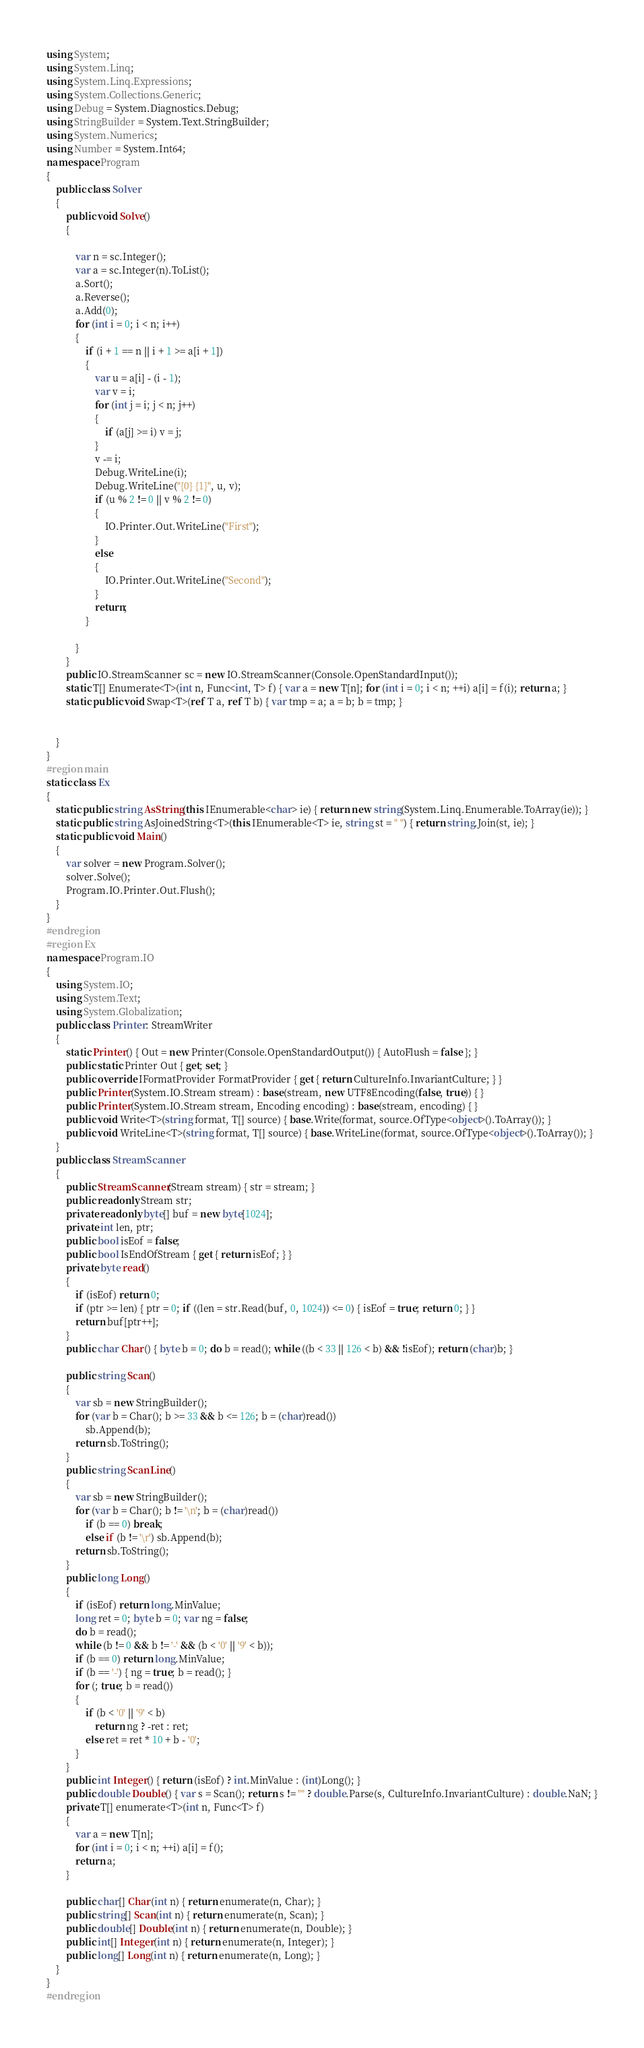Convert code to text. <code><loc_0><loc_0><loc_500><loc_500><_C#_>using System;
using System.Linq;
using System.Linq.Expressions;
using System.Collections.Generic;
using Debug = System.Diagnostics.Debug;
using StringBuilder = System.Text.StringBuilder;
using System.Numerics;
using Number = System.Int64;
namespace Program
{
    public class Solver
    {
        public void Solve()
        {

            var n = sc.Integer();
            var a = sc.Integer(n).ToList();
            a.Sort();
            a.Reverse();
            a.Add(0);
            for (int i = 0; i < n; i++)
            {
                if (i + 1 == n || i + 1 >= a[i + 1])
                {
                    var u = a[i] - (i - 1);
                    var v = i;
                    for (int j = i; j < n; j++)
                    {
                        if (a[j] >= i) v = j;
                    }
                    v -= i;
                    Debug.WriteLine(i);
                    Debug.WriteLine("{0} {1}", u, v);
                    if (u % 2 != 0 || v % 2 != 0)
                    {
                        IO.Printer.Out.WriteLine("First");
                    }
                    else
                    {
                        IO.Printer.Out.WriteLine("Second");
                    }
                    return;
                }

            }
        }
        public IO.StreamScanner sc = new IO.StreamScanner(Console.OpenStandardInput());
        static T[] Enumerate<T>(int n, Func<int, T> f) { var a = new T[n]; for (int i = 0; i < n; ++i) a[i] = f(i); return a; }
        static public void Swap<T>(ref T a, ref T b) { var tmp = a; a = b; b = tmp; }


    }
}
#region main
static class Ex
{
    static public string AsString(this IEnumerable<char> ie) { return new string(System.Linq.Enumerable.ToArray(ie)); }
    static public string AsJoinedString<T>(this IEnumerable<T> ie, string st = " ") { return string.Join(st, ie); }
    static public void Main()
    {
        var solver = new Program.Solver();
        solver.Solve();
        Program.IO.Printer.Out.Flush();
    }
}
#endregion
#region Ex
namespace Program.IO
{
    using System.IO;
    using System.Text;
    using System.Globalization;
    public class Printer: StreamWriter
    {
        static Printer() { Out = new Printer(Console.OpenStandardOutput()) { AutoFlush = false }; }
        public static Printer Out { get; set; }
        public override IFormatProvider FormatProvider { get { return CultureInfo.InvariantCulture; } }
        public Printer(System.IO.Stream stream) : base(stream, new UTF8Encoding(false, true)) { }
        public Printer(System.IO.Stream stream, Encoding encoding) : base(stream, encoding) { }
        public void Write<T>(string format, T[] source) { base.Write(format, source.OfType<object>().ToArray()); }
        public void WriteLine<T>(string format, T[] source) { base.WriteLine(format, source.OfType<object>().ToArray()); }
    }
    public class StreamScanner
    {
        public StreamScanner(Stream stream) { str = stream; }
        public readonly Stream str;
        private readonly byte[] buf = new byte[1024];
        private int len, ptr;
        public bool isEof = false;
        public bool IsEndOfStream { get { return isEof; } }
        private byte read()
        {
            if (isEof) return 0;
            if (ptr >= len) { ptr = 0; if ((len = str.Read(buf, 0, 1024)) <= 0) { isEof = true; return 0; } }
            return buf[ptr++];
        }
        public char Char() { byte b = 0; do b = read(); while ((b < 33 || 126 < b) && !isEof); return (char)b; }

        public string Scan()
        {
            var sb = new StringBuilder();
            for (var b = Char(); b >= 33 && b <= 126; b = (char)read())
                sb.Append(b);
            return sb.ToString();
        }
        public string ScanLine()
        {
            var sb = new StringBuilder();
            for (var b = Char(); b != '\n'; b = (char)read())
                if (b == 0) break;
                else if (b != '\r') sb.Append(b);
            return sb.ToString();
        }
        public long Long()
        {
            if (isEof) return long.MinValue;
            long ret = 0; byte b = 0; var ng = false;
            do b = read();
            while (b != 0 && b != '-' && (b < '0' || '9' < b));
            if (b == 0) return long.MinValue;
            if (b == '-') { ng = true; b = read(); }
            for (; true; b = read())
            {
                if (b < '0' || '9' < b)
                    return ng ? -ret : ret;
                else ret = ret * 10 + b - '0';
            }
        }
        public int Integer() { return (isEof) ? int.MinValue : (int)Long(); }
        public double Double() { var s = Scan(); return s != "" ? double.Parse(s, CultureInfo.InvariantCulture) : double.NaN; }
        private T[] enumerate<T>(int n, Func<T> f)
        {
            var a = new T[n];
            for (int i = 0; i < n; ++i) a[i] = f();
            return a;
        }

        public char[] Char(int n) { return enumerate(n, Char); }
        public string[] Scan(int n) { return enumerate(n, Scan); }
        public double[] Double(int n) { return enumerate(n, Double); }
        public int[] Integer(int n) { return enumerate(n, Integer); }
        public long[] Long(int n) { return enumerate(n, Long); }
    }
}
#endregion
</code> 